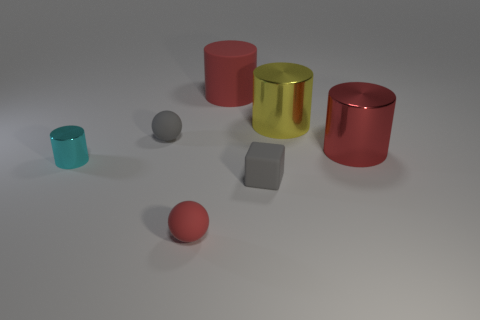Subtract all small cyan metal cylinders. How many cylinders are left? 3 Subtract all cyan cylinders. How many cylinders are left? 3 Add 1 yellow cylinders. How many objects exist? 8 Subtract all green cylinders. Subtract all blue blocks. How many cylinders are left? 4 Subtract all balls. How many objects are left? 5 Add 6 big red shiny things. How many big red shiny things are left? 7 Add 4 metal cylinders. How many metal cylinders exist? 7 Subtract 0 yellow blocks. How many objects are left? 7 Subtract all big brown rubber objects. Subtract all red metallic objects. How many objects are left? 6 